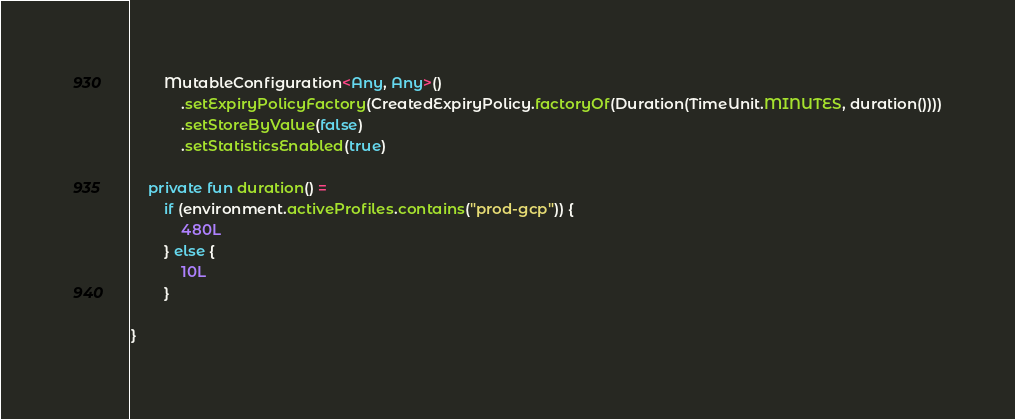<code> <loc_0><loc_0><loc_500><loc_500><_Kotlin_>        MutableConfiguration<Any, Any>()
            .setExpiryPolicyFactory(CreatedExpiryPolicy.factoryOf(Duration(TimeUnit.MINUTES, duration())))
            .setStoreByValue(false)
            .setStatisticsEnabled(true)

    private fun duration() =
        if (environment.activeProfiles.contains("prod-gcp")) {
            480L
        } else {
            10L
        }

}
</code> 